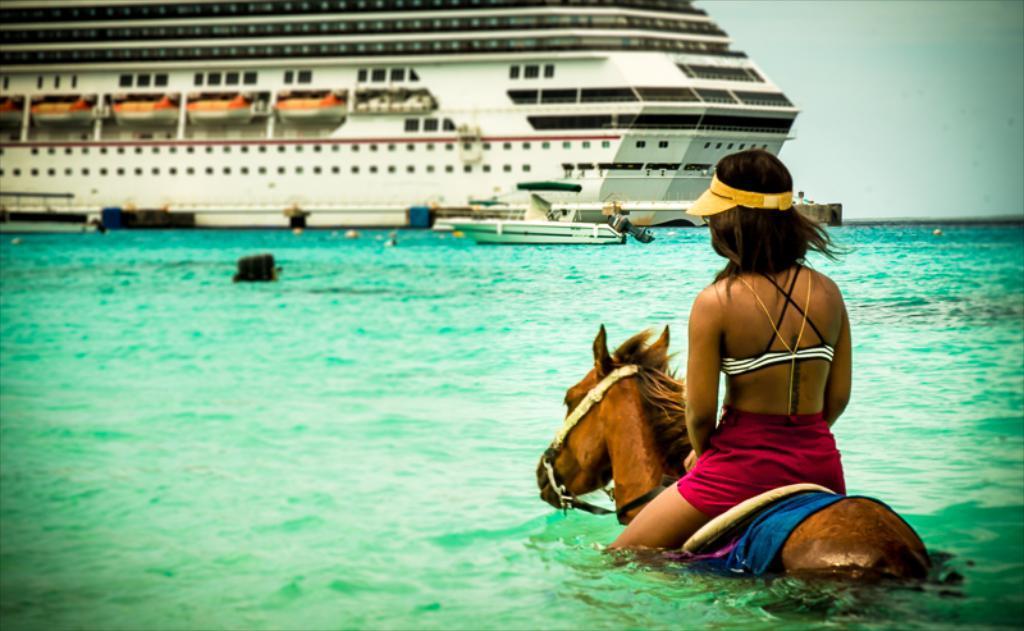Can you describe this image briefly? there is a person sitting on a horse in the water. at the back there is a ship. 